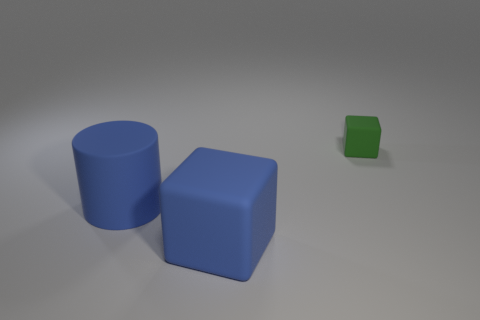Add 1 big brown rubber spheres. How many objects exist? 4 Subtract all cubes. How many objects are left? 1 Add 1 big red balls. How many big red balls exist? 1 Subtract 0 green cylinders. How many objects are left? 3 Subtract all cubes. Subtract all green metallic cubes. How many objects are left? 1 Add 1 cylinders. How many cylinders are left? 2 